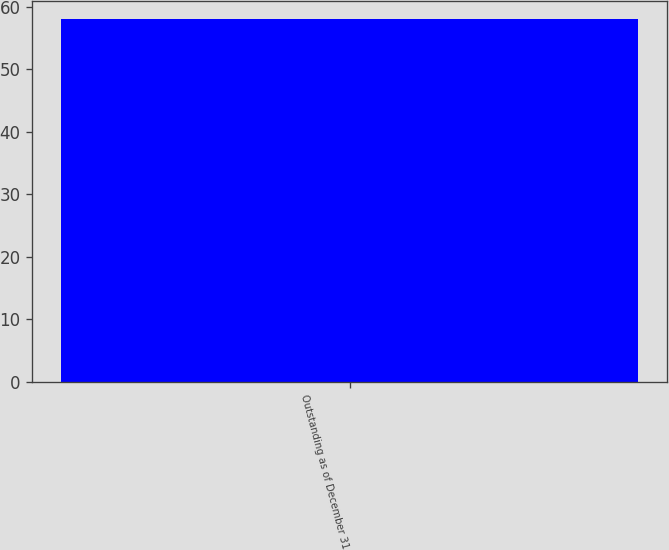Convert chart. <chart><loc_0><loc_0><loc_500><loc_500><bar_chart><fcel>Outstanding as of December 31<nl><fcel>58<nl></chart> 